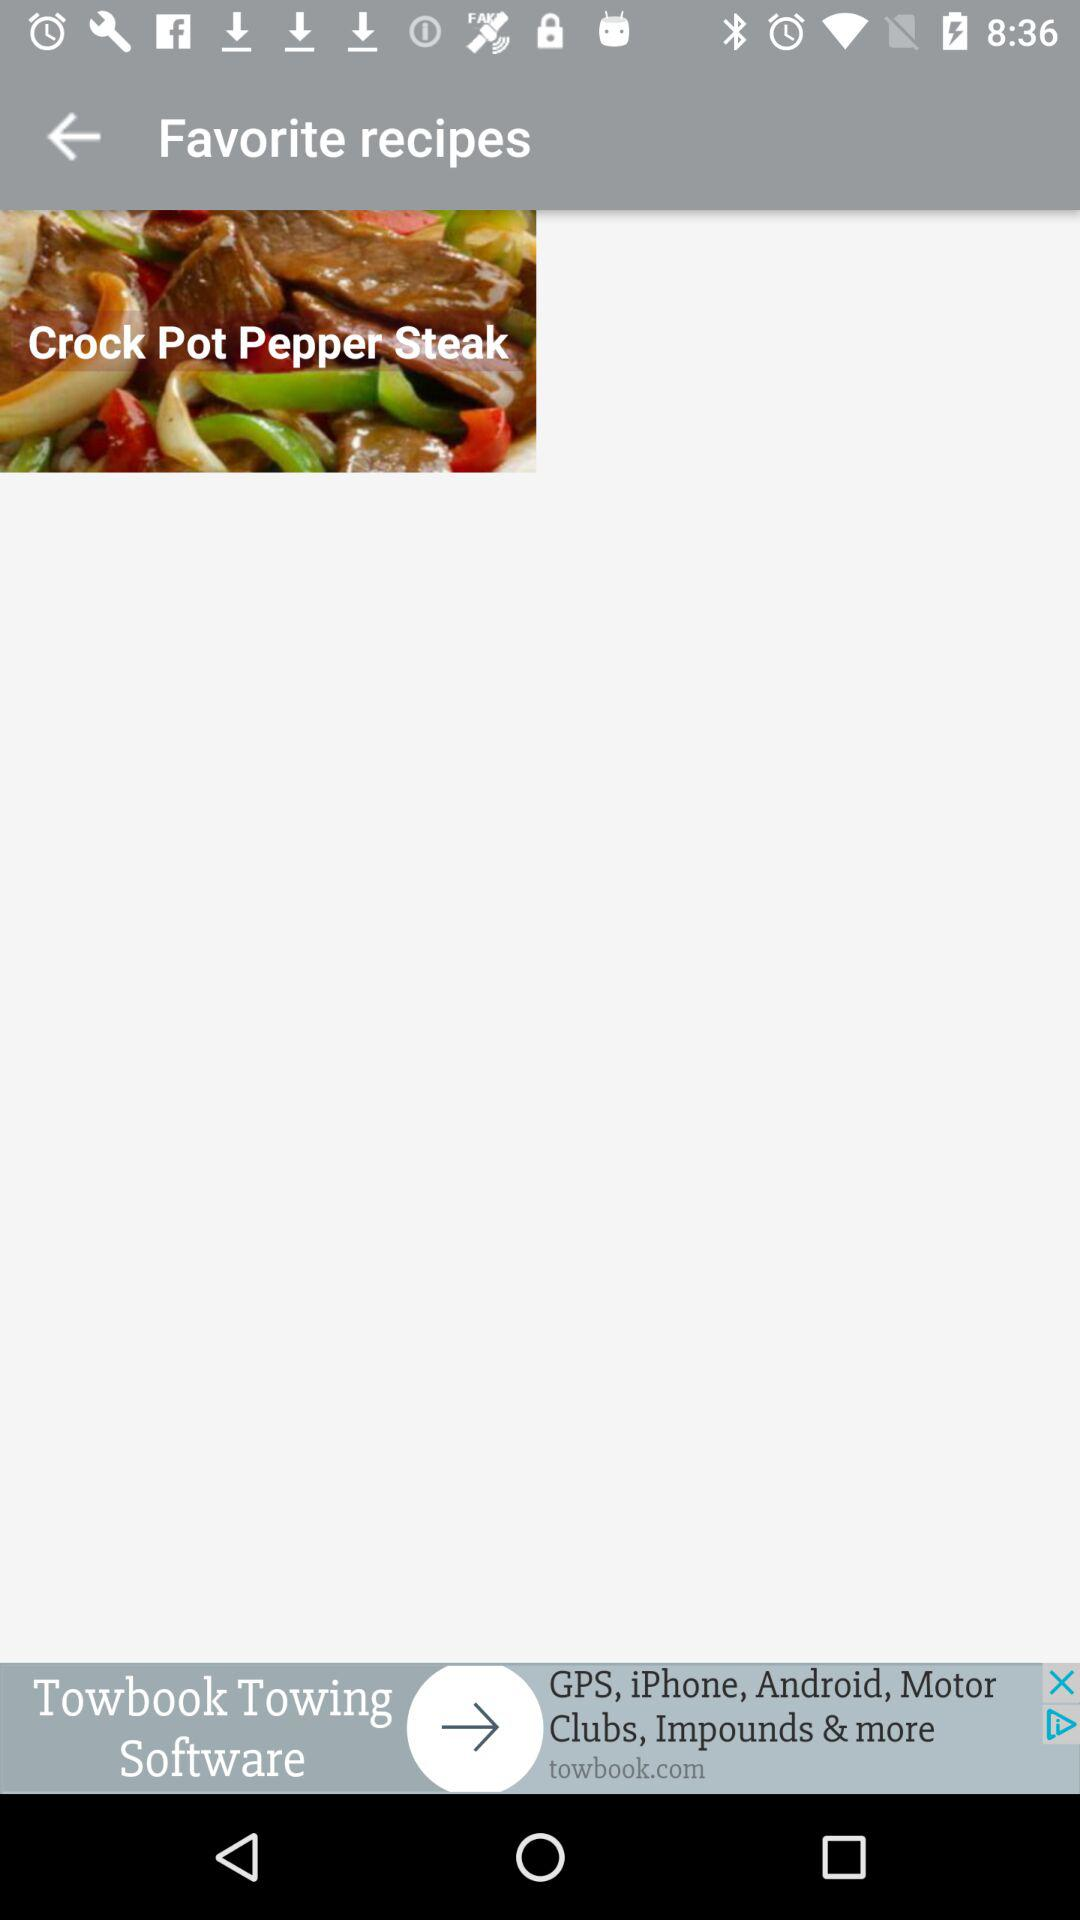What is the favorite recipe? The favorite recipe is "Crock Pot Pepper Steak". 